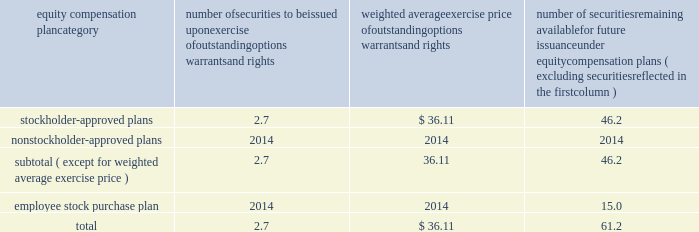Bhge 2018 form 10-k | 107 part iii item 10 .
Directors , executive officers and corporate governance information regarding our code of conduct , the spirit and the letter , and code of ethical conduct certificates for our principal executive officer , principal financial officer and principal accounting officer are described in item 1 .
Business of this annual report .
Information concerning our directors is set forth in the sections entitled "proposal no .
1 , election of directors - board nominees for directors" and "corporate governance - committees of the board" in our definitive proxy statement for the 2019 annual meeting of stockholders to be filed with the sec pursuant to the exchange act within 120 days of the end of our fiscal year on december 31 , 2018 ( proxy statement ) , which sections are incorporated herein by reference .
For information regarding our executive officers , see "item 1 .
Business - executive officers of baker hughes" in this annual report on form 10-k .
Additional information regarding compliance by directors and executive officers with section 16 ( a ) of the exchange act is set forth under the section entitled "section 16 ( a ) beneficial ownership reporting compliance" in our proxy statement , which section is incorporated herein by reference .
Item 11 .
Executive compensation information for this item is set forth in the following sections of our proxy statement , which sections are incorporated herein by reference : "compensation discussion and analysis" "director compensation" "compensation committee interlocks and insider participation" and "compensation committee report." item 12 .
Security ownership of certain beneficial owners and management and related stockholder matters information concerning security ownership of certain beneficial owners and our management is set forth in the sections entitled "stock ownership of certain beneficial owners" and 201cstock ownership of section 16 ( a ) director and executive officers 201d in our proxy statement , which sections are incorporated herein by reference .
We permit our employees , officers and directors to enter into written trading plans complying with rule 10b5-1 under the exchange act .
Rule 10b5-1 provides criteria under which such an individual may establish a prearranged plan to buy or sell a specified number of shares of a company's stock over a set period of time .
Any such plan must be entered into in good faith at a time when the individual is not in possession of material , nonpublic information .
If an individual establishes a plan satisfying the requirements of rule 10b5-1 , such individual's subsequent receipt of material , nonpublic information will not prevent transactions under the plan from being executed .
Certain of our officers have advised us that they have and may enter into stock sales plans for the sale of shares of our class a common stock which are intended to comply with the requirements of rule 10b5-1 of the exchange act .
In addition , the company has and may in the future enter into repurchases of our class a common stock under a plan that complies with rule 10b5-1 or rule 10b-18 of the exchange act .
Equity compensation plan information the information in the table is presented as of december 31 , 2018 with respect to shares of our class a common stock that may be issued under our lti plan which has been approved by our stockholders ( in millions , except per share prices ) .
Equity compensation plan category number of securities to be issued upon exercise of outstanding options , warrants and rights weighted average exercise price of outstanding options , warrants and rights number of securities remaining available for future issuance under equity compensation plans ( excluding securities reflected in the first column ) .

What is the total value of the number of securities approved by stockholders , in millions? 
Computations: (2.7 * 36.11)
Answer: 97.497. 